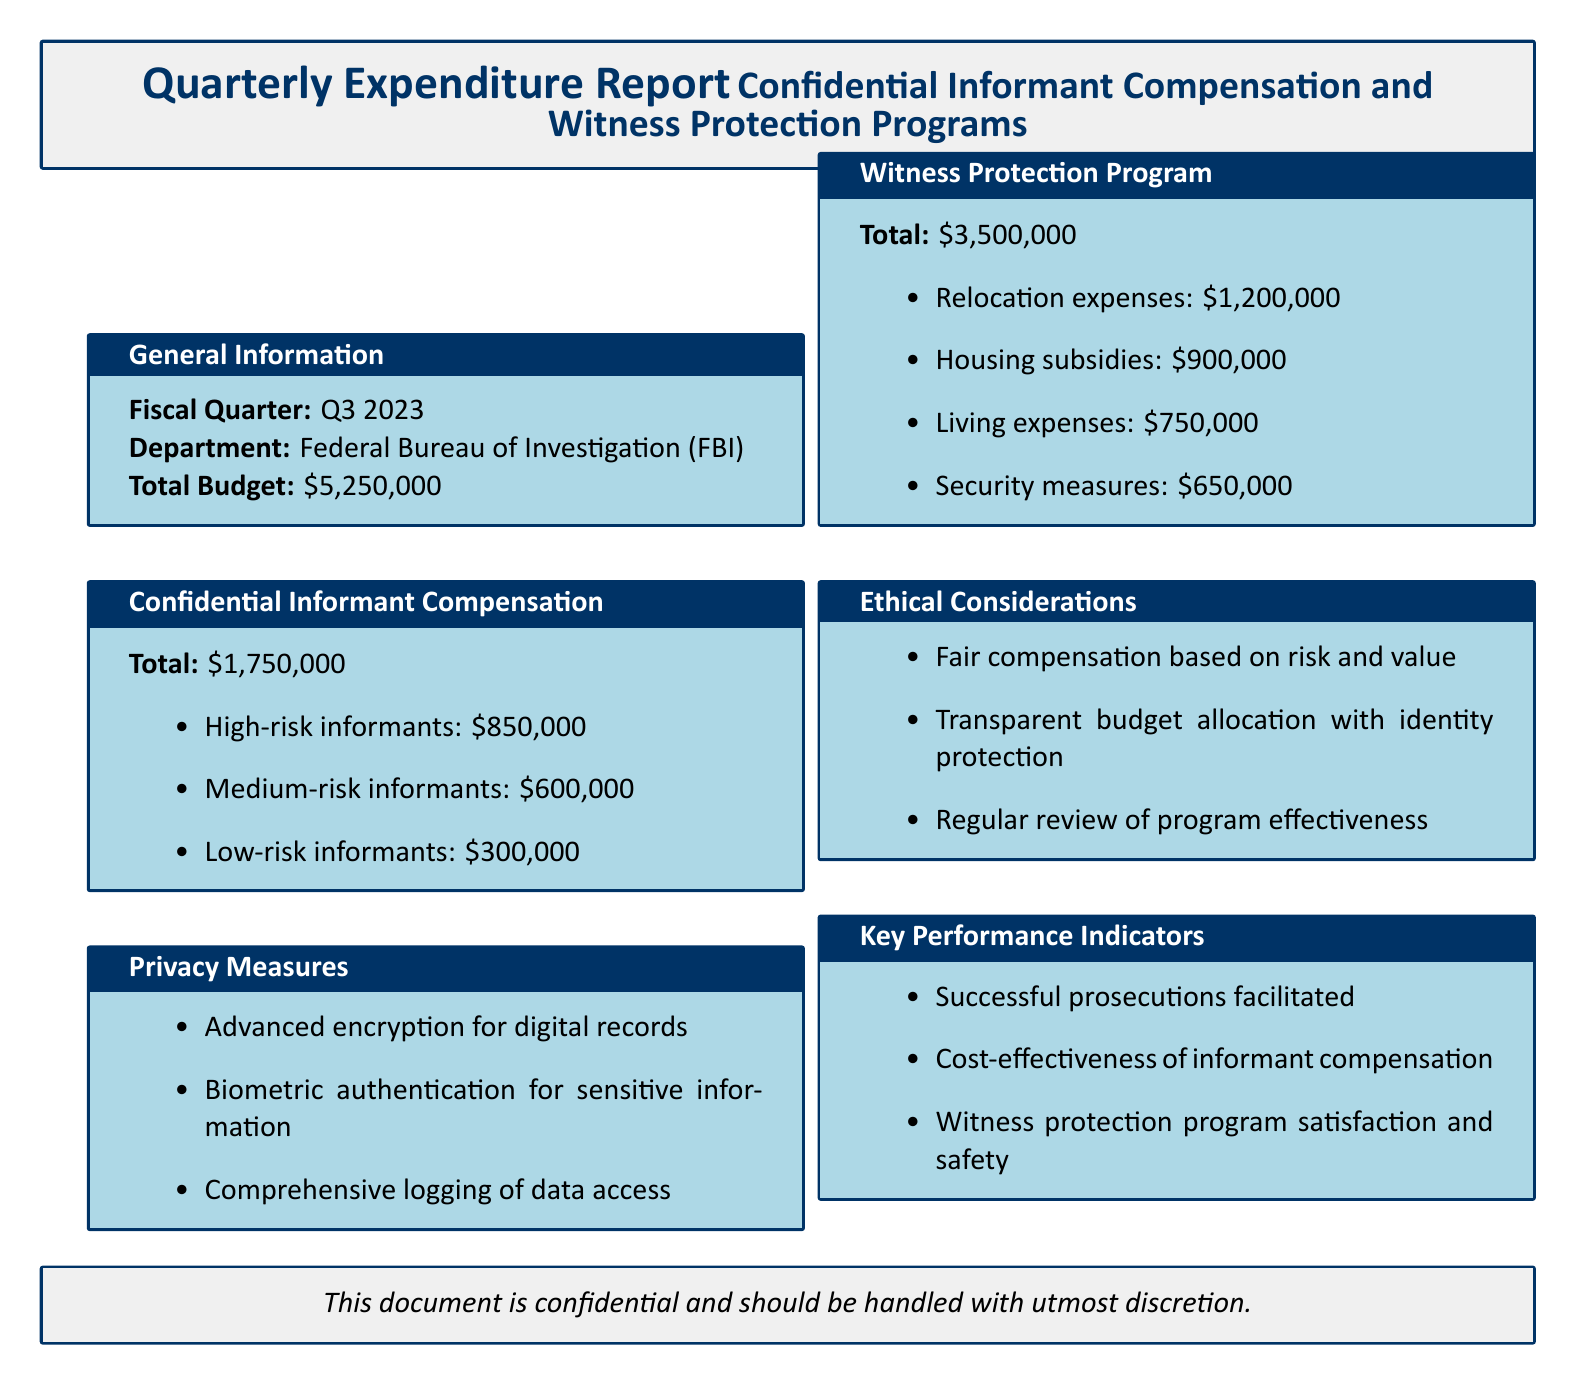What is the fiscal quarter covered in the report? The fiscal quarter is explicitly stated in the document, which is Q3 2023.
Answer: Q3 2023 What is the total budget for the programs? The total budget is mentioned at the beginning of the document as $5,250,000.
Answer: $5,250,000 How much is allocated for high-risk informants? The amount allocated for high-risk informants is detailed under the Confidential Informant Compensation section as $850,000.
Answer: $850,000 What is the total expenditure for the Witness Protection Program? This total is specified in the Witness Protection Program section as $3,500,000.
Answer: $3,500,000 What measures are included to ensure privacy? Privacy measures are explicitly listed in the document under a dedicated section, including advanced encryption, biometric authentication, and comprehensive logging of data access.
Answer: Advanced encryption for digital records What percentage of the total budget is used for confidential informant compensation? This requires calculating the proportion of the confidential informant compensation amount in relation to the total budget, which is $1,750,000 out of $5,250,000.
Answer: 33.33% What is the amount allocated for relocation expenses in the Witness Protection Program? The amount for relocation expenses is directly provided in the Witness Protection Program section as $1,200,000.
Answer: $1,200,000 What ethical consideration is mentioned regarding compensation? An ethical consideration listed involves fair compensation based on risk and value, which is specifically stated.
Answer: Fair compensation based on risk and value What key performance indicator relates to informant compensation? The key performance indicator that relates to informant compensation is included under the Key Performance Indicators section as cost-effectiveness of informant compensation.
Answer: Cost-effectiveness of informant compensation 